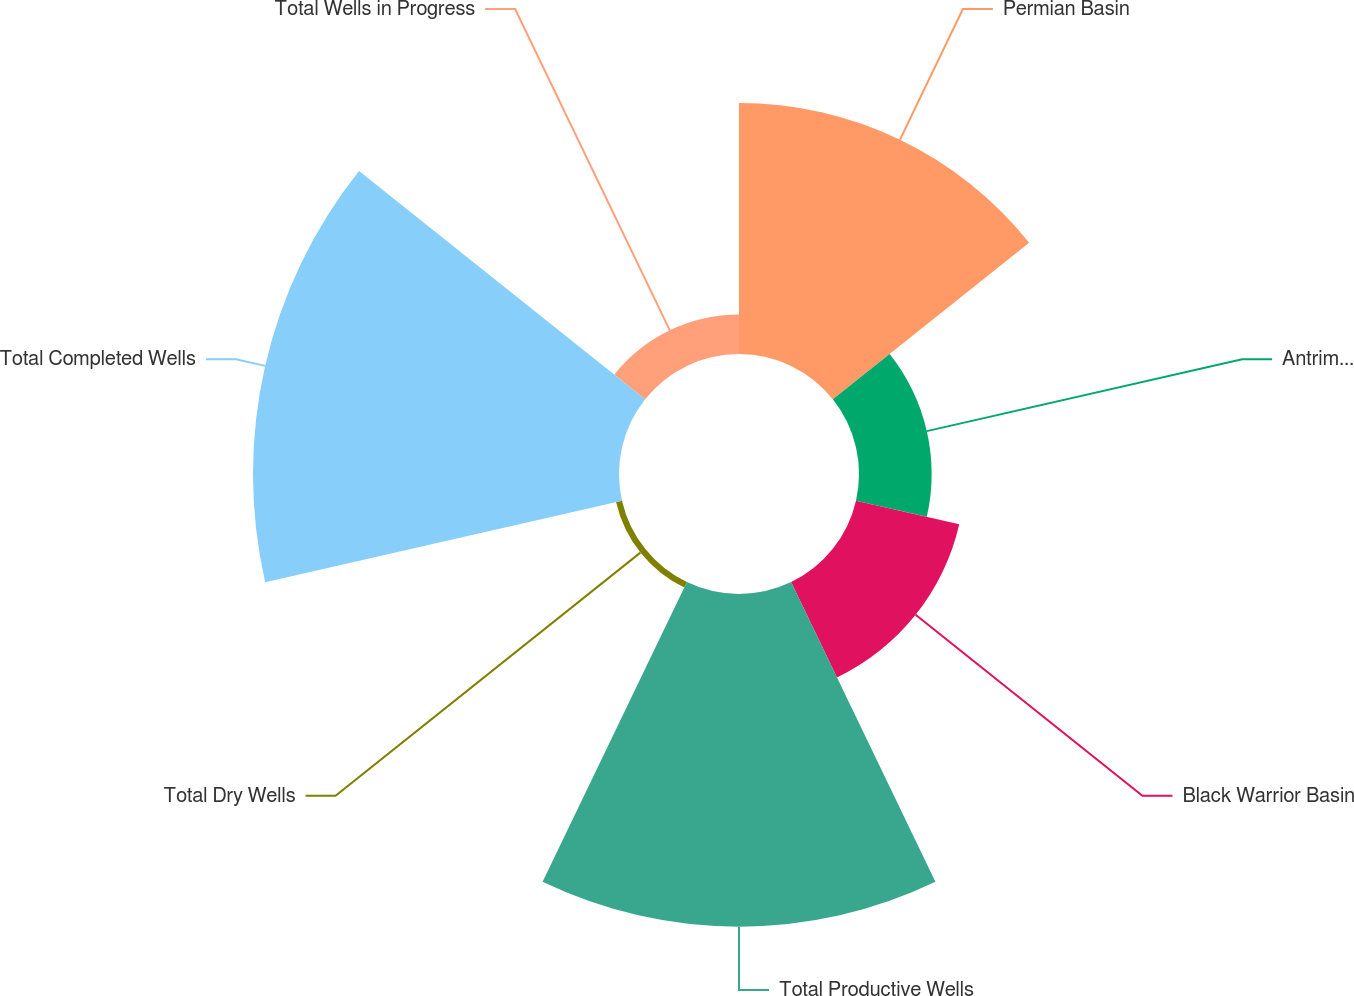Convert chart to OTSL. <chart><loc_0><loc_0><loc_500><loc_500><pie_chart><fcel>Permian Basin<fcel>Antrim Shale<fcel>Black Warrior Basin<fcel>Total Productive Wells<fcel>Total Dry Wells<fcel>Total Completed Wells<fcel>Total Wells in Progress<nl><fcel>21.39%<fcel>6.19%<fcel>9.02%<fcel>28.34%<fcel>0.52%<fcel>31.18%<fcel>3.36%<nl></chart> 